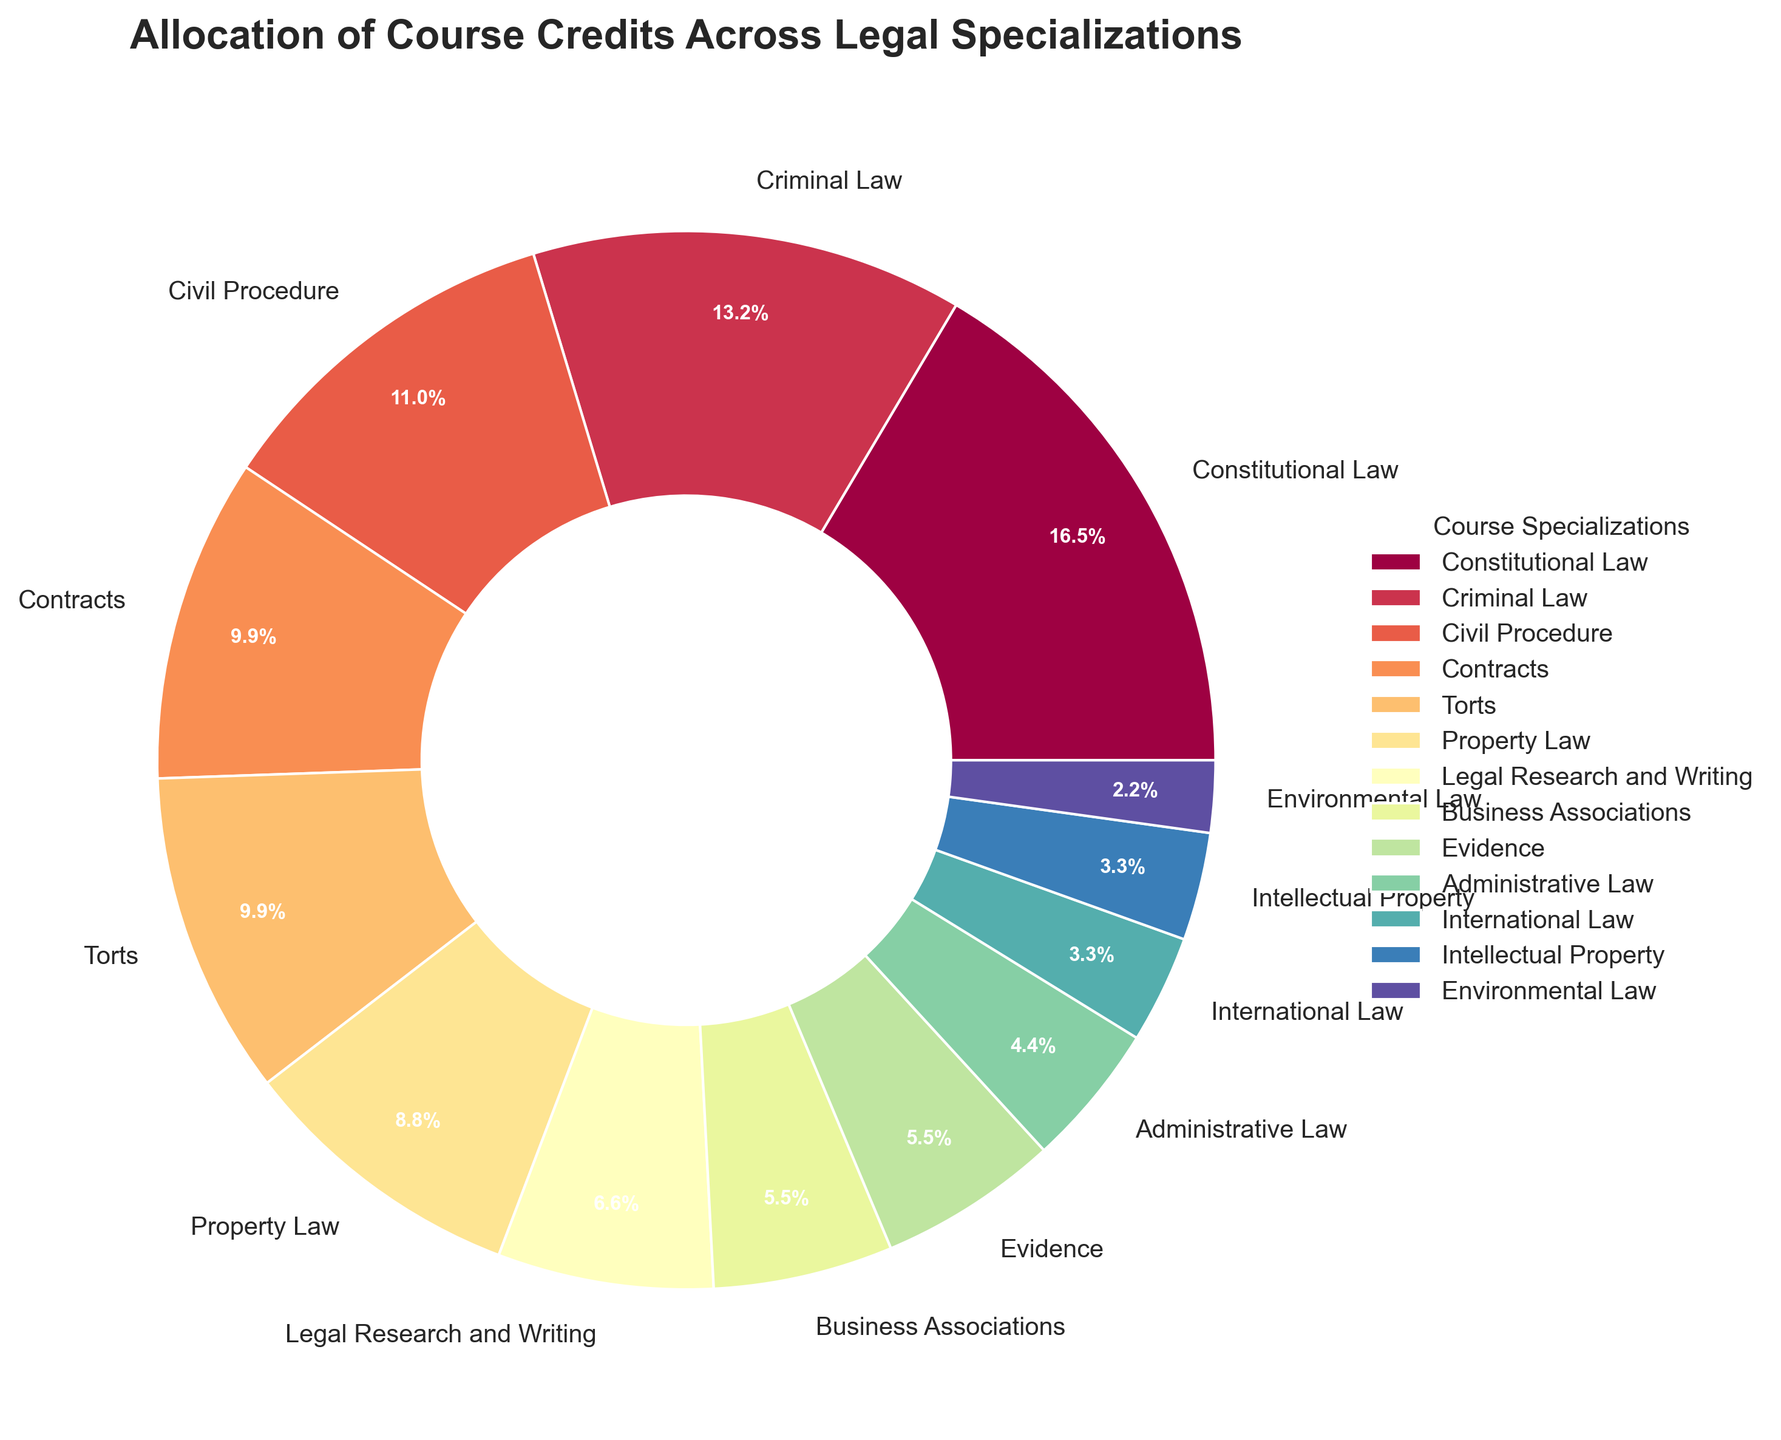Which course specialization has the highest allocation of credit hours? Look at the sector with the largest size in the pie chart, which corresponds to the course with the most credit hours.
Answer: Constitutional Law What percentage of the total credits is allocated to Criminal Law and Civil Procedure combined? Criminal Law has 12 credit hours, and Civil Procedure has 10 credit hours. Combine them for a total of 22 credit hours. The total credit hours across all courses are 91. Calculate (22/91) * 100 to get the percentage.
Answer: 24.2% Which courses have the same number of credit hours? Look for sectors in the pie chart that appear to be the same size. Both Contracts and Torts have 9 credit hours each.
Answer: Contracts and Torts How does the allocation for Constitutional Law compare to Evidence and Administrative Law combined? Constitutional Law has 15 credit hours. Evidence and Administrative Law have 5 and 4 credit hours, respectively, giving a total of 9 for the two combined. 15 (Constitutional Law) is greater than 9 (Evidence + Administrative Law).
Answer: Greater What is the smallest course specialization in terms of credit hours? Find the smallest sector in the pie chart to identify the course with the least credit hours.
Answer: Environmental Law What fraction of the total credit hours is allocated to Business Associations compared to Criminal Law? Business Associations has 5 credit hours, and Criminal Law has 12 credit hours. The fraction is 5/12.
Answer: 5/12 Are there any specializations that have credit hours less than the average credit hours per specialization? Calculate the average credit hours by dividing the total credit hours (91) by the number of specializations (13). The average is 7 credit hours. Specializations with less than 7 credit hours include International Law, Intellectual Property, and Environmental Law.
Answer: Yes What is the total number of credit hours allocated to all legal specializations with fewer than 10 credit hours? Add the credit hours for all courses with fewer than 10 credit hours: Property Law (8), Legal Research and Writing (6), Business Associations (5), Evidence (5), Administrative Law (4), International Law (3), Intellectual Property (3), Environmental Law (2). Sum these values: 8 + 6 + 5 + 5 + 4 + 3 + 3 + 2 = 36.
Answer: 36 What is the ratio of credit hours between Property Law and International Law? Property Law has 8 credit hours, and International Law has 3 credit hours. The ratio is 8/3.
Answer: 8/3 How many specializations have more credit hours than Legal Research and Writing? Legal Research and Writing has 6 credit hours. Count the number of specializations with more than 6 credit hours: Constitutional Law, Criminal Law, Civil Procedure, Contracts, Torts, Property Law. There are 6 such specializations.
Answer: 6 